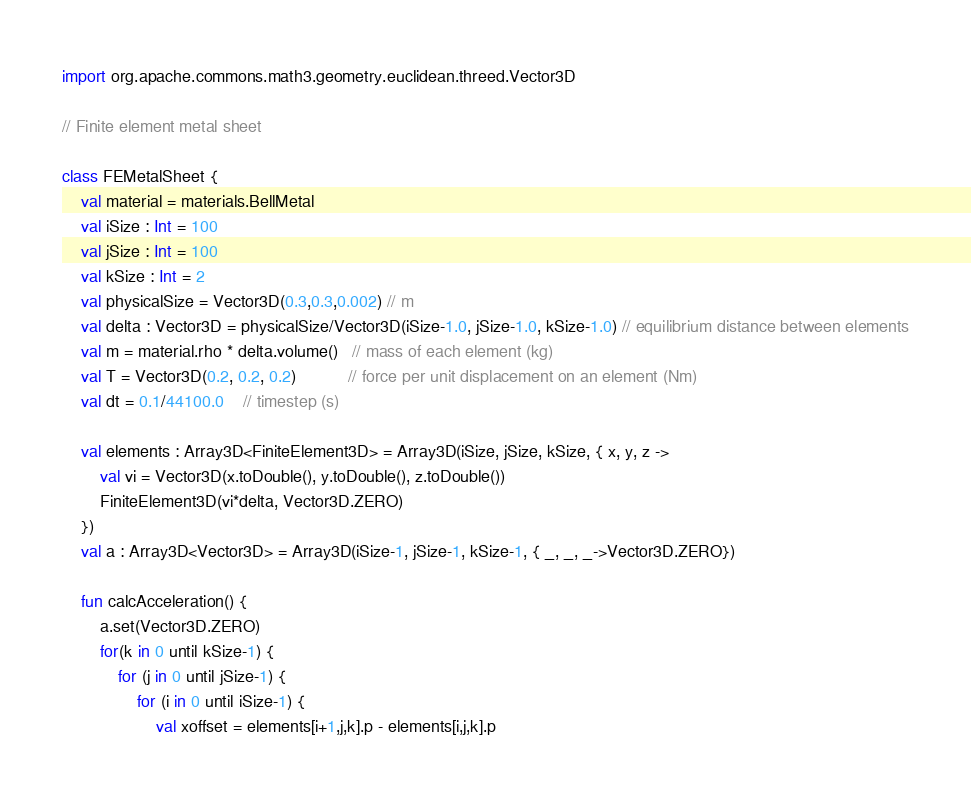<code> <loc_0><loc_0><loc_500><loc_500><_Kotlin_>import org.apache.commons.math3.geometry.euclidean.threed.Vector3D

// Finite element metal sheet

class FEMetalSheet {
    val material = materials.BellMetal
    val iSize : Int = 100
    val jSize : Int = 100
    val kSize : Int = 2
    val physicalSize = Vector3D(0.3,0.3,0.002) // m
    val delta : Vector3D = physicalSize/Vector3D(iSize-1.0, jSize-1.0, kSize-1.0) // equilibrium distance between elements
    val m = material.rho * delta.volume()   // mass of each element (kg)
    val T = Vector3D(0.2, 0.2, 0.2)           // force per unit displacement on an element (Nm)
    val dt = 0.1/44100.0    // timestep (s)

    val elements : Array3D<FiniteElement3D> = Array3D(iSize, jSize, kSize, { x, y, z ->
        val vi = Vector3D(x.toDouble(), y.toDouble(), z.toDouble())
        FiniteElement3D(vi*delta, Vector3D.ZERO)
    })
    val a : Array3D<Vector3D> = Array3D(iSize-1, jSize-1, kSize-1, { _, _, _->Vector3D.ZERO})

    fun calcAcceleration() {
        a.set(Vector3D.ZERO)
        for(k in 0 until kSize-1) {
            for (j in 0 until jSize-1) {
                for (i in 0 until iSize-1) {
                    val xoffset = elements[i+1,j,k].p - elements[i,j,k].p</code> 